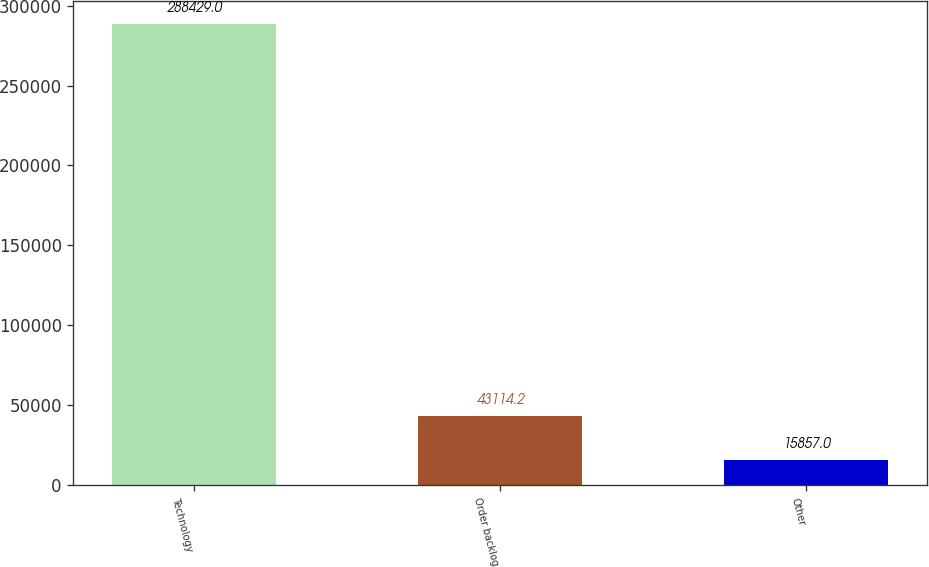Convert chart. <chart><loc_0><loc_0><loc_500><loc_500><bar_chart><fcel>Technology<fcel>Order backlog<fcel>Other<nl><fcel>288429<fcel>43114.2<fcel>15857<nl></chart> 